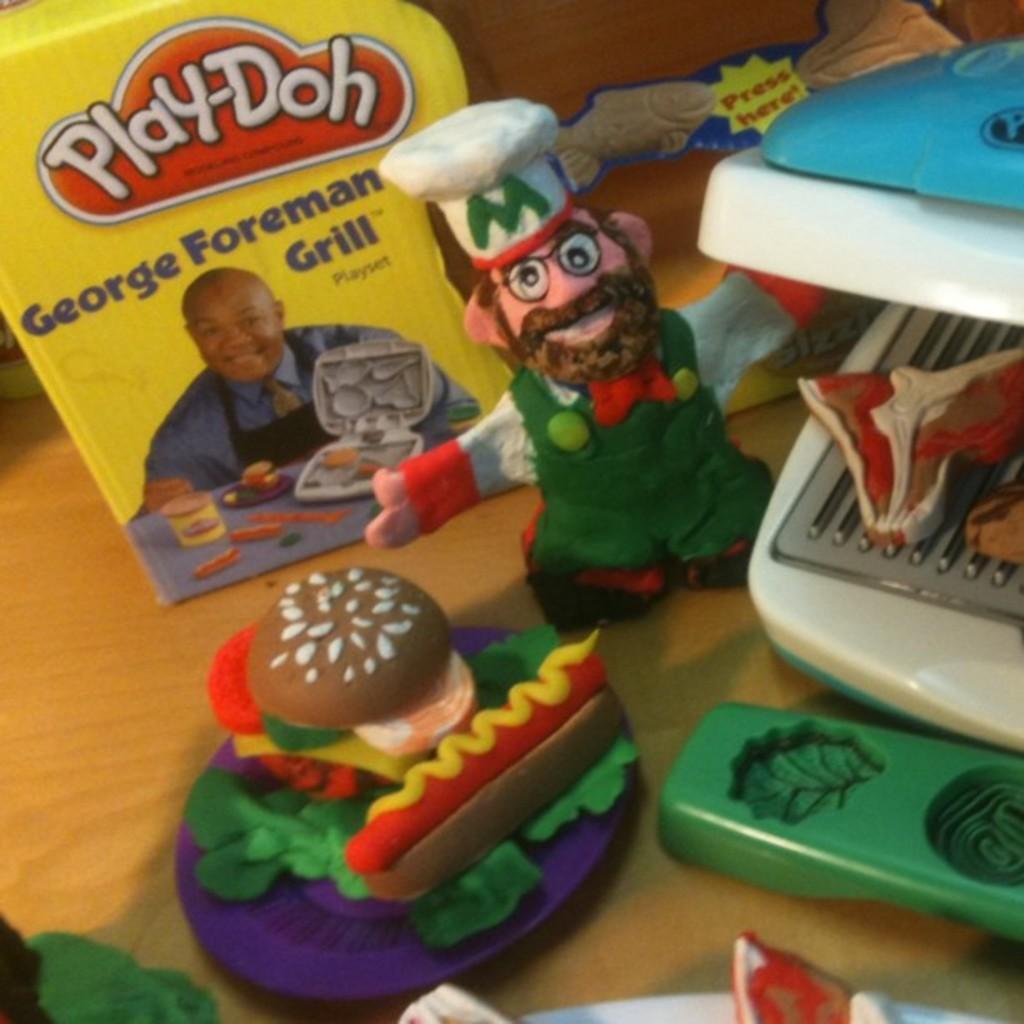In one or two sentences, can you explain what this image depicts? This image is taken indoors. At the bottom of the image there is a table with a few clay toys and molds on it. On the right side of the image there is a sandwich maker and a sandwich made with clay in it. There is a box with a text on it. 